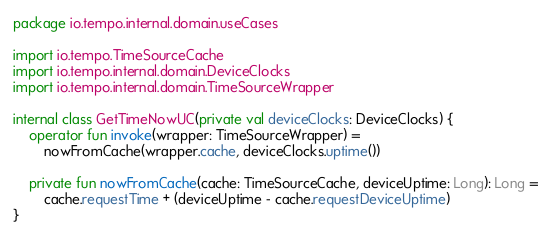<code> <loc_0><loc_0><loc_500><loc_500><_Kotlin_>package io.tempo.internal.domain.useCases

import io.tempo.TimeSourceCache
import io.tempo.internal.domain.DeviceClocks
import io.tempo.internal.domain.TimeSourceWrapper

internal class GetTimeNowUC(private val deviceClocks: DeviceClocks) {
    operator fun invoke(wrapper: TimeSourceWrapper) =
        nowFromCache(wrapper.cache, deviceClocks.uptime())

    private fun nowFromCache(cache: TimeSourceCache, deviceUptime: Long): Long =
        cache.requestTime + (deviceUptime - cache.requestDeviceUptime)
}</code> 